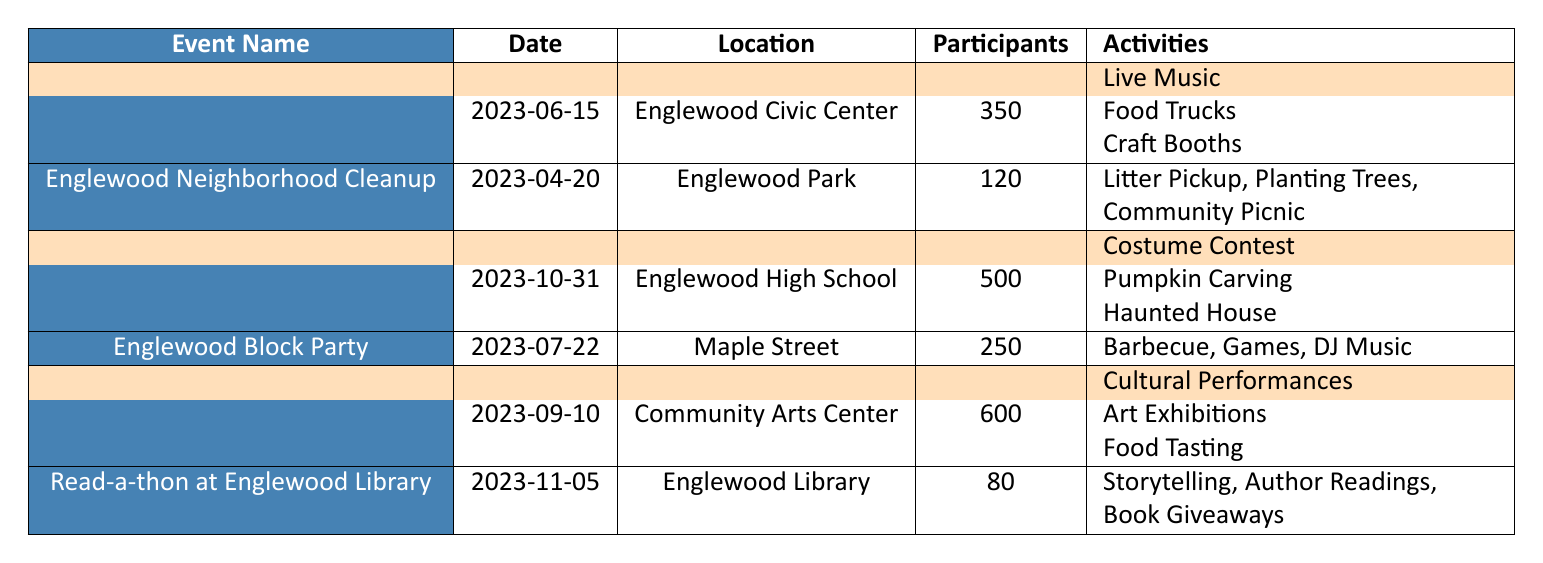What is the date of the Englewood Cultural Festival? The table lists the Englewood Cultural Festival along with its details, and its date is indicated as 2023-09-10.
Answer: 2023-09-10 How many participants attended the Halloween Festival? In the table, the Halloween Festival has a participant count of 500 listed next to it.
Answer: 500 Which event had the highest number of participants? By comparing the participant counts in the table, the Englewood Cultural Festival has 600 participants, which is the highest.
Answer: Englewood Cultural Festival What activities were available at the Englewood Community Fair? The table shows that the Englewood Community Fair included Live Music, Food Trucks, and Craft Booths as its activities.
Answer: Live Music, Food Trucks, Craft Booths How many events had more than 300 participants? The Englewood Community Fair, Halloween Festival, and Englewood Cultural Festival had participant counts of 350, 500, and 600, respectively. So there are three events with over 300 participants.
Answer: 3 What is the average number of participants across all events? The total sum of participants for all events is 350 + 120 + 500 + 250 + 600 + 80 = 1900. There are 6 events, so the average is 1900 / 6 = 316.67.
Answer: 316.67 Did the Englewood Block Party have more participants than the Englewood Neighborhood Cleanup? The Englewood Block Party had 250 participants, while the Englewood Neighborhood Cleanup had 120, so yes, it had more participants.
Answer: Yes Which event took place at the Englewood High School? The table indicates that the Halloween Festival took place at the Englewood High School.
Answer: Halloween Festival What activities are listed for the Read-a-thon at Englewood Library? According to the table, the activities at the Read-a-thon include Storytelling, Author Readings, and Book Giveaways.
Answer: Storytelling, Author Readings, Book Giveaways How does the number of participants at the Englewood Neighborhood Cleanup compare to the Halloween Festival? The Englewood Neighborhood Cleanup had 120 participants while the Halloween Festival had 500 participants, which means the Halloween Festival had significantly more participants than the cleanup event.
Answer: Halloween Festival had more participants What is the total number of participants from all highlighted events? The highlighted events are the Englewood Community Fair (350), Halloween Festival (500), and Englewood Cultural Festival (600). The total is 350 + 500 + 600 = 1450 participants.
Answer: 1450 